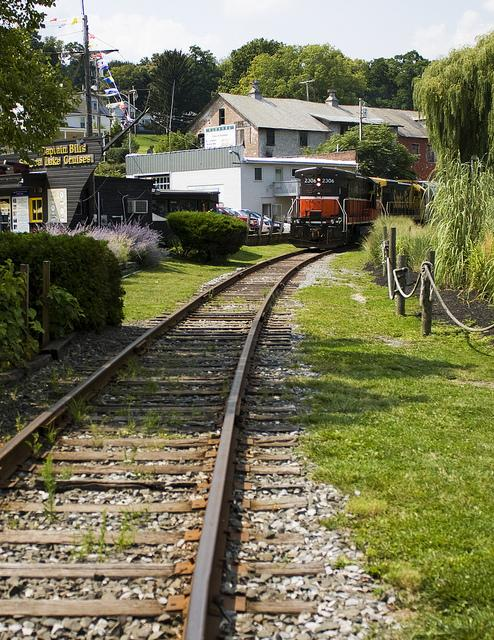What color is the lateral stripe around the train engine?

Choices:
A) white
B) blue
C) red
D) green red 